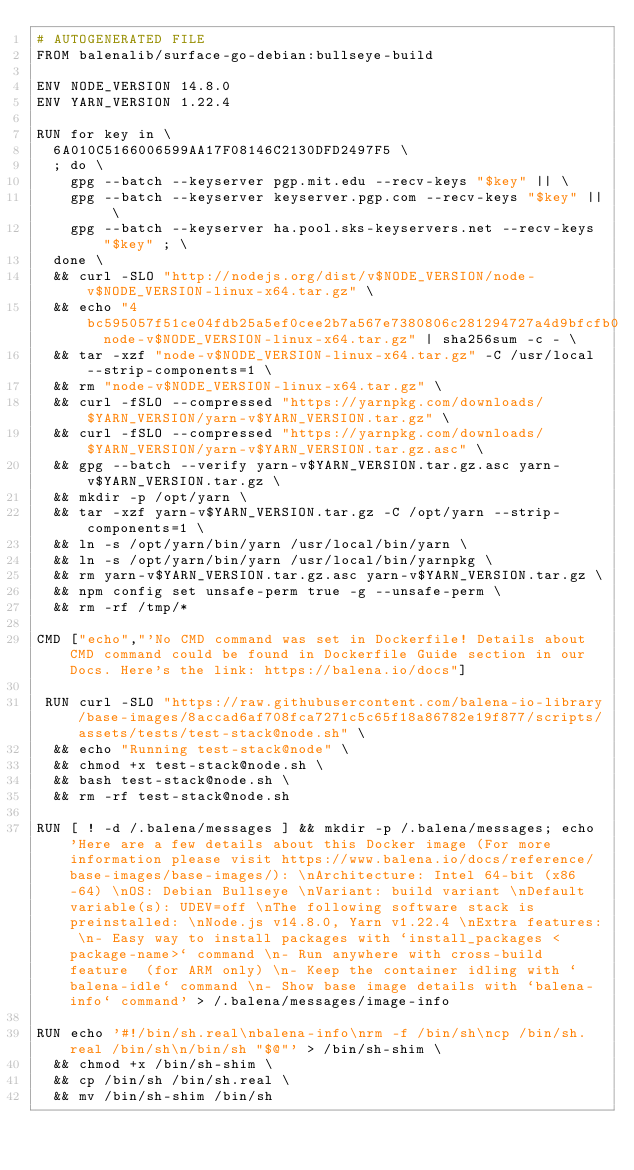<code> <loc_0><loc_0><loc_500><loc_500><_Dockerfile_># AUTOGENERATED FILE
FROM balenalib/surface-go-debian:bullseye-build

ENV NODE_VERSION 14.8.0
ENV YARN_VERSION 1.22.4

RUN for key in \
	6A010C5166006599AA17F08146C2130DFD2497F5 \
	; do \
		gpg --batch --keyserver pgp.mit.edu --recv-keys "$key" || \
		gpg --batch --keyserver keyserver.pgp.com --recv-keys "$key" || \
		gpg --batch --keyserver ha.pool.sks-keyservers.net --recv-keys "$key" ; \
	done \
	&& curl -SLO "http://nodejs.org/dist/v$NODE_VERSION/node-v$NODE_VERSION-linux-x64.tar.gz" \
	&& echo "4bc595057f51ce04fdb25a5ef0cee2b7a567e7380806c281294727a4d9bfcfb0  node-v$NODE_VERSION-linux-x64.tar.gz" | sha256sum -c - \
	&& tar -xzf "node-v$NODE_VERSION-linux-x64.tar.gz" -C /usr/local --strip-components=1 \
	&& rm "node-v$NODE_VERSION-linux-x64.tar.gz" \
	&& curl -fSLO --compressed "https://yarnpkg.com/downloads/$YARN_VERSION/yarn-v$YARN_VERSION.tar.gz" \
	&& curl -fSLO --compressed "https://yarnpkg.com/downloads/$YARN_VERSION/yarn-v$YARN_VERSION.tar.gz.asc" \
	&& gpg --batch --verify yarn-v$YARN_VERSION.tar.gz.asc yarn-v$YARN_VERSION.tar.gz \
	&& mkdir -p /opt/yarn \
	&& tar -xzf yarn-v$YARN_VERSION.tar.gz -C /opt/yarn --strip-components=1 \
	&& ln -s /opt/yarn/bin/yarn /usr/local/bin/yarn \
	&& ln -s /opt/yarn/bin/yarn /usr/local/bin/yarnpkg \
	&& rm yarn-v$YARN_VERSION.tar.gz.asc yarn-v$YARN_VERSION.tar.gz \
	&& npm config set unsafe-perm true -g --unsafe-perm \
	&& rm -rf /tmp/*

CMD ["echo","'No CMD command was set in Dockerfile! Details about CMD command could be found in Dockerfile Guide section in our Docs. Here's the link: https://balena.io/docs"]

 RUN curl -SLO "https://raw.githubusercontent.com/balena-io-library/base-images/8accad6af708fca7271c5c65f18a86782e19f877/scripts/assets/tests/test-stack@node.sh" \
  && echo "Running test-stack@node" \
  && chmod +x test-stack@node.sh \
  && bash test-stack@node.sh \
  && rm -rf test-stack@node.sh 

RUN [ ! -d /.balena/messages ] && mkdir -p /.balena/messages; echo 'Here are a few details about this Docker image (For more information please visit https://www.balena.io/docs/reference/base-images/base-images/): \nArchitecture: Intel 64-bit (x86-64) \nOS: Debian Bullseye \nVariant: build variant \nDefault variable(s): UDEV=off \nThe following software stack is preinstalled: \nNode.js v14.8.0, Yarn v1.22.4 \nExtra features: \n- Easy way to install packages with `install_packages <package-name>` command \n- Run anywhere with cross-build feature  (for ARM only) \n- Keep the container idling with `balena-idle` command \n- Show base image details with `balena-info` command' > /.balena/messages/image-info

RUN echo '#!/bin/sh.real\nbalena-info\nrm -f /bin/sh\ncp /bin/sh.real /bin/sh\n/bin/sh "$@"' > /bin/sh-shim \
	&& chmod +x /bin/sh-shim \
	&& cp /bin/sh /bin/sh.real \
	&& mv /bin/sh-shim /bin/sh</code> 